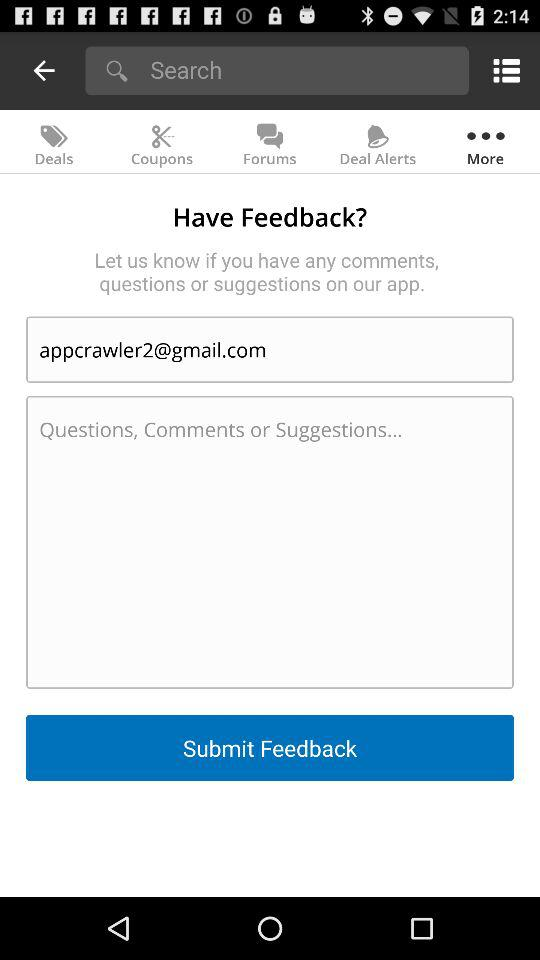Which tab is selected? The selected tab is "More". 